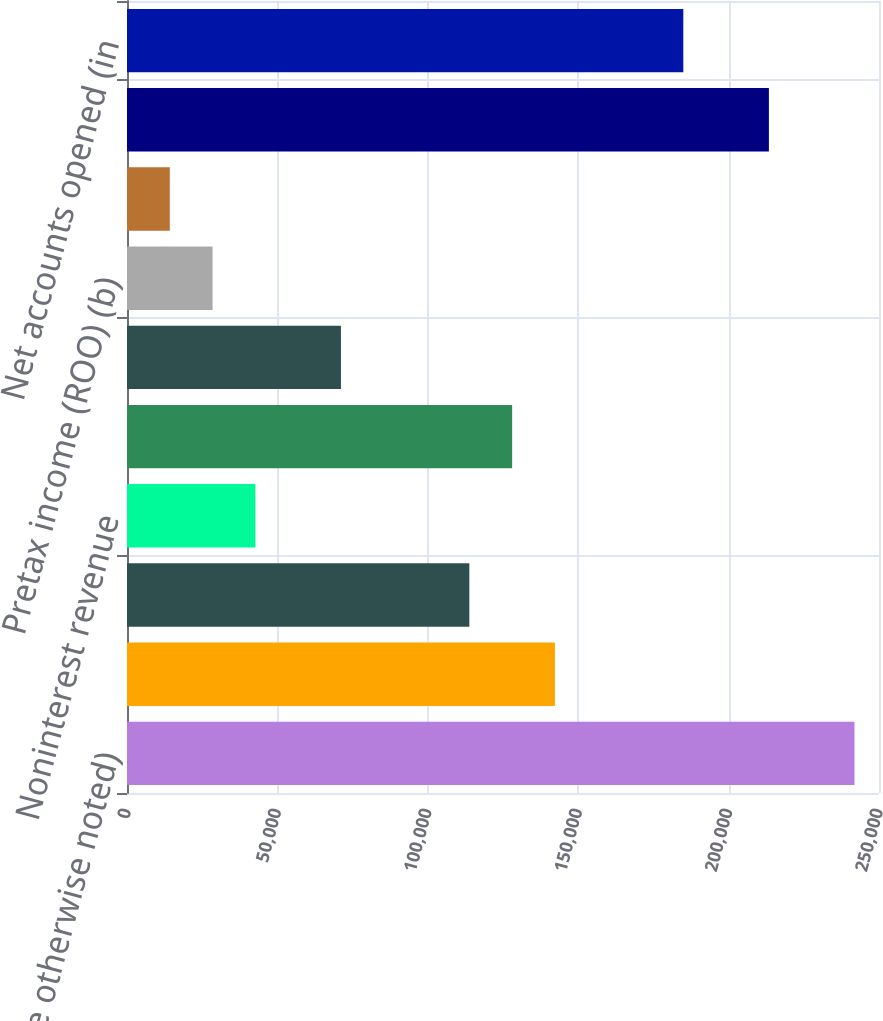Convert chart to OTSL. <chart><loc_0><loc_0><loc_500><loc_500><bar_chart><fcel>and where otherwise noted)<fcel>Net interest income<fcel>Provision for credit losses<fcel>Noninterest revenue<fcel>Risk adjusted margin (a)<fcel>Noninterest expense<fcel>Pretax income (ROO) (b)<fcel>Net income<fcel>Charge volume (in billions)<fcel>Net accounts opened (in<nl><fcel>241850<fcel>142265<fcel>113812<fcel>42680.4<fcel>128039<fcel>71133.1<fcel>28454<fcel>14227.6<fcel>213397<fcel>184944<nl></chart> 